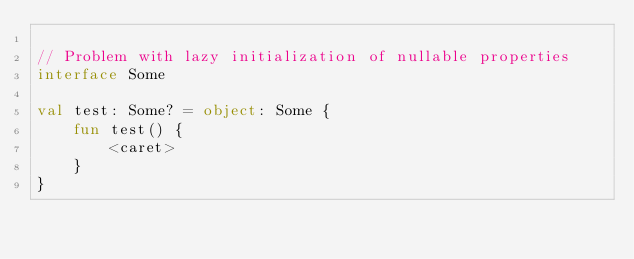Convert code to text. <code><loc_0><loc_0><loc_500><loc_500><_Kotlin_>
// Problem with lazy initialization of nullable properties
interface Some

val test: Some? = object: Some {
    fun test() {
        <caret>
    }
}</code> 